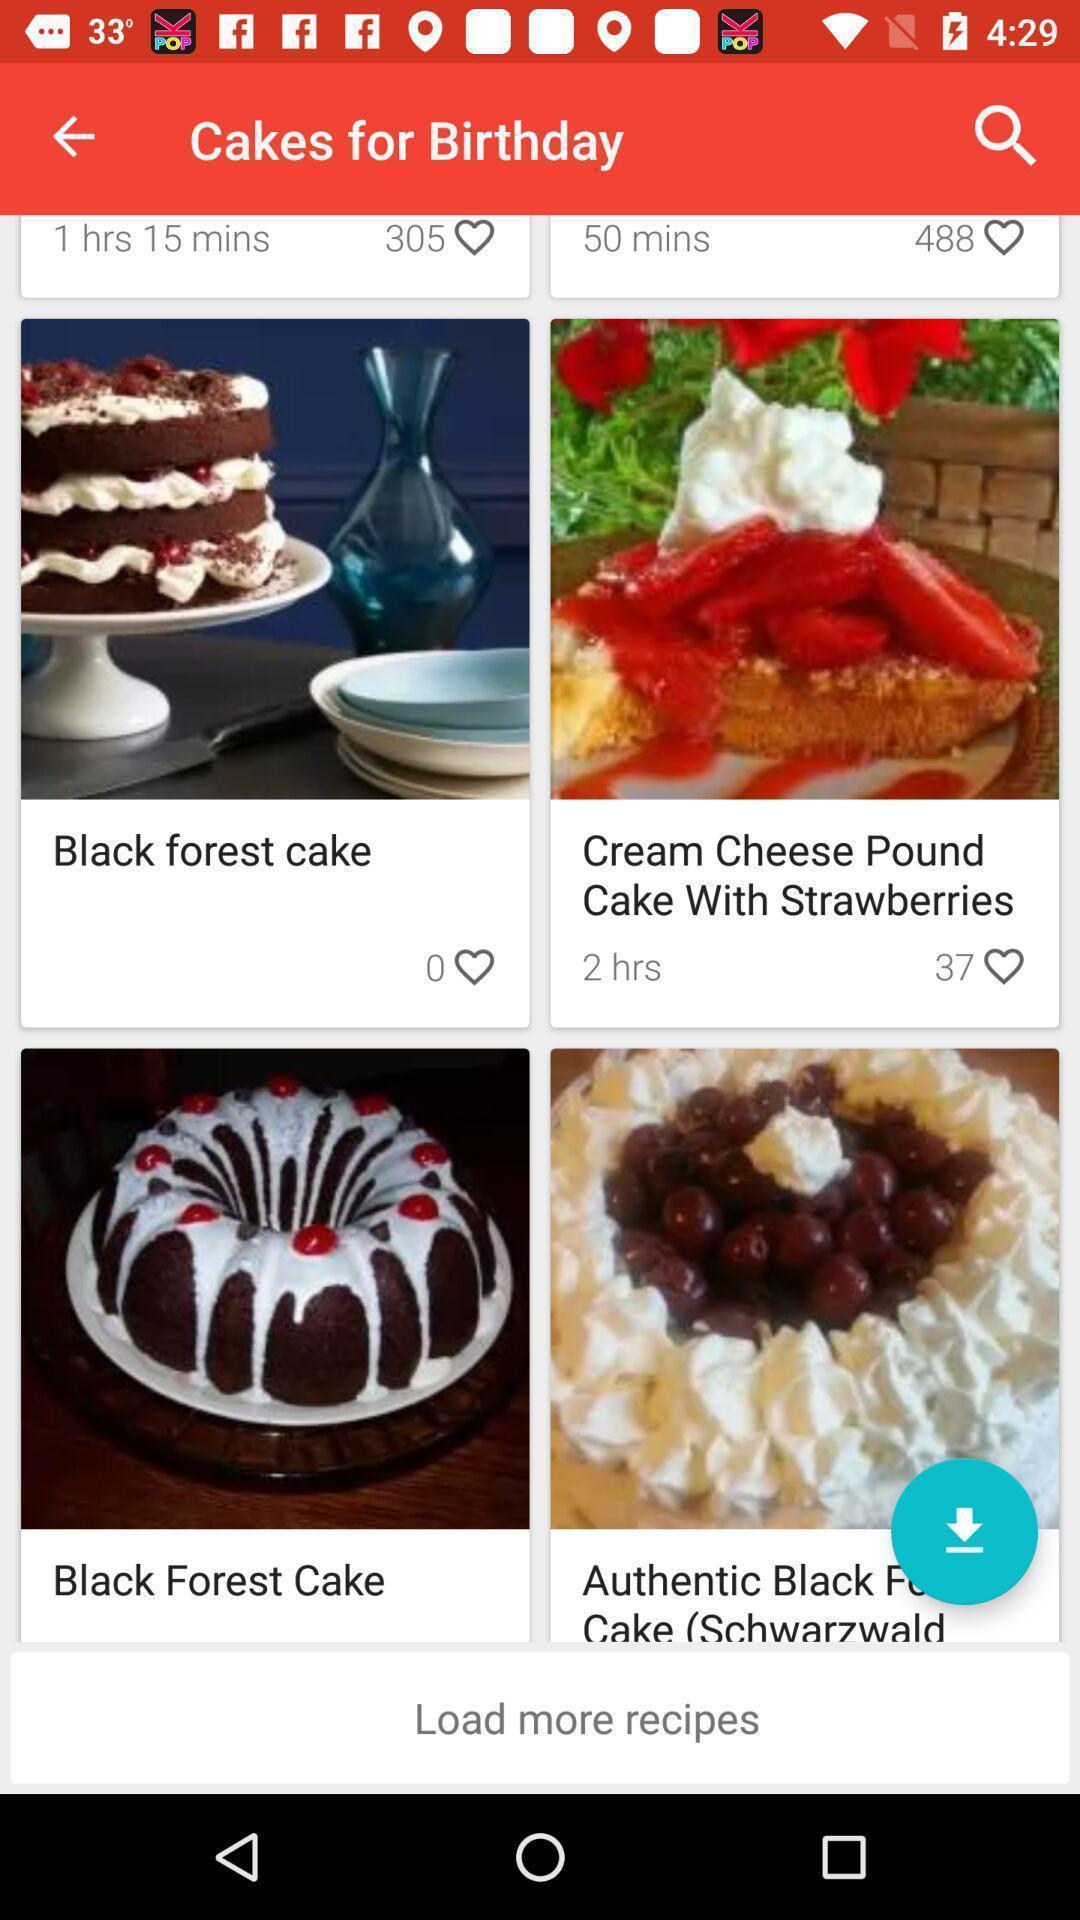What is the overall content of this screenshot? Screen displaying multiple cake images with names. 